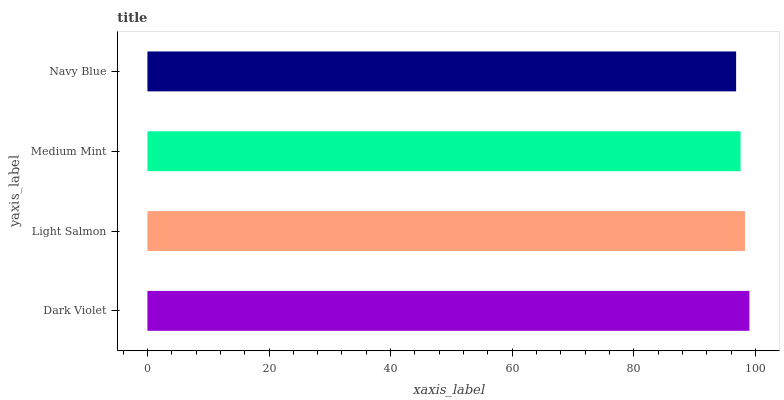Is Navy Blue the minimum?
Answer yes or no. Yes. Is Dark Violet the maximum?
Answer yes or no. Yes. Is Light Salmon the minimum?
Answer yes or no. No. Is Light Salmon the maximum?
Answer yes or no. No. Is Dark Violet greater than Light Salmon?
Answer yes or no. Yes. Is Light Salmon less than Dark Violet?
Answer yes or no. Yes. Is Light Salmon greater than Dark Violet?
Answer yes or no. No. Is Dark Violet less than Light Salmon?
Answer yes or no. No. Is Light Salmon the high median?
Answer yes or no. Yes. Is Medium Mint the low median?
Answer yes or no. Yes. Is Dark Violet the high median?
Answer yes or no. No. Is Dark Violet the low median?
Answer yes or no. No. 